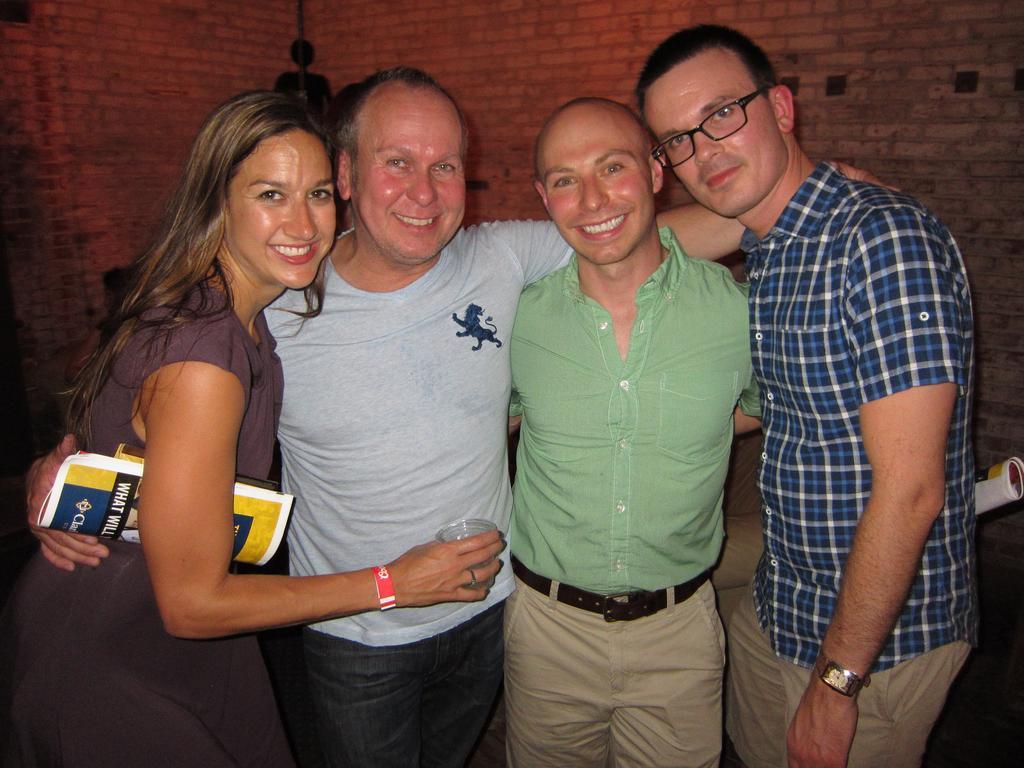How would you summarize this image in a sentence or two? In this image, we can see people standing and some are smiling and there is a lady carrying a paper and holding an object and there is a man wearing glasses. In the background, there is a wall and we can see some objects. 